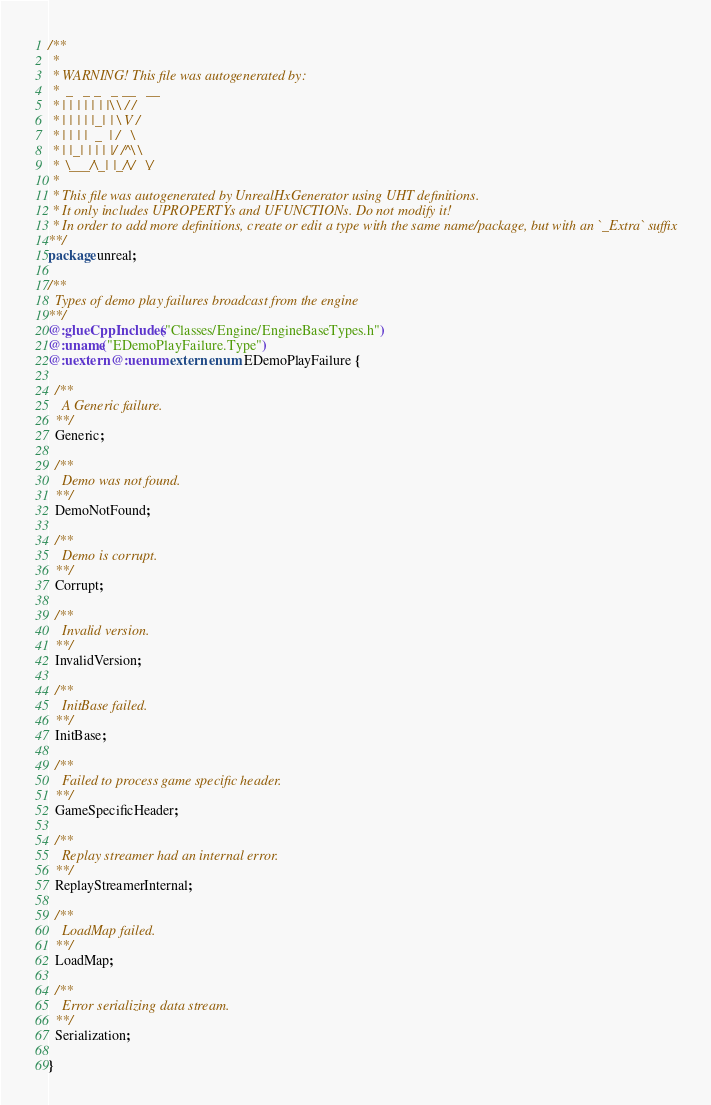Convert code to text. <code><loc_0><loc_0><loc_500><loc_500><_Haxe_>/**
 * 
 * WARNING! This file was autogenerated by: 
 *  _   _ _   _ __   __ 
 * | | | | | | |\ \ / / 
 * | | | | |_| | \ V /  
 * | | | |  _  | /   \  
 * | |_| | | | |/ /^\ \ 
 *  \___/\_| |_/\/   \/ 
 * 
 * This file was autogenerated by UnrealHxGenerator using UHT definitions.
 * It only includes UPROPERTYs and UFUNCTIONs. Do not modify it!
 * In order to add more definitions, create or edit a type with the same name/package, but with an `_Extra` suffix
**/
package unreal;

/**
  Types of demo play failures broadcast from the engine
**/
@:glueCppIncludes("Classes/Engine/EngineBaseTypes.h")
@:uname("EDemoPlayFailure.Type")
@:uextern @:uenum extern enum EDemoPlayFailure {
  
  /**
    A Generic failure.
  **/
  Generic;
  
  /**
    Demo was not found.
  **/
  DemoNotFound;
  
  /**
    Demo is corrupt.
  **/
  Corrupt;
  
  /**
    Invalid version.
  **/
  InvalidVersion;
  
  /**
    InitBase failed.
  **/
  InitBase;
  
  /**
    Failed to process game specific header.
  **/
  GameSpecificHeader;
  
  /**
    Replay streamer had an internal error.
  **/
  ReplayStreamerInternal;
  
  /**
    LoadMap failed.
  **/
  LoadMap;
  
  /**
    Error serializing data stream.
  **/
  Serialization;
  
}
</code> 